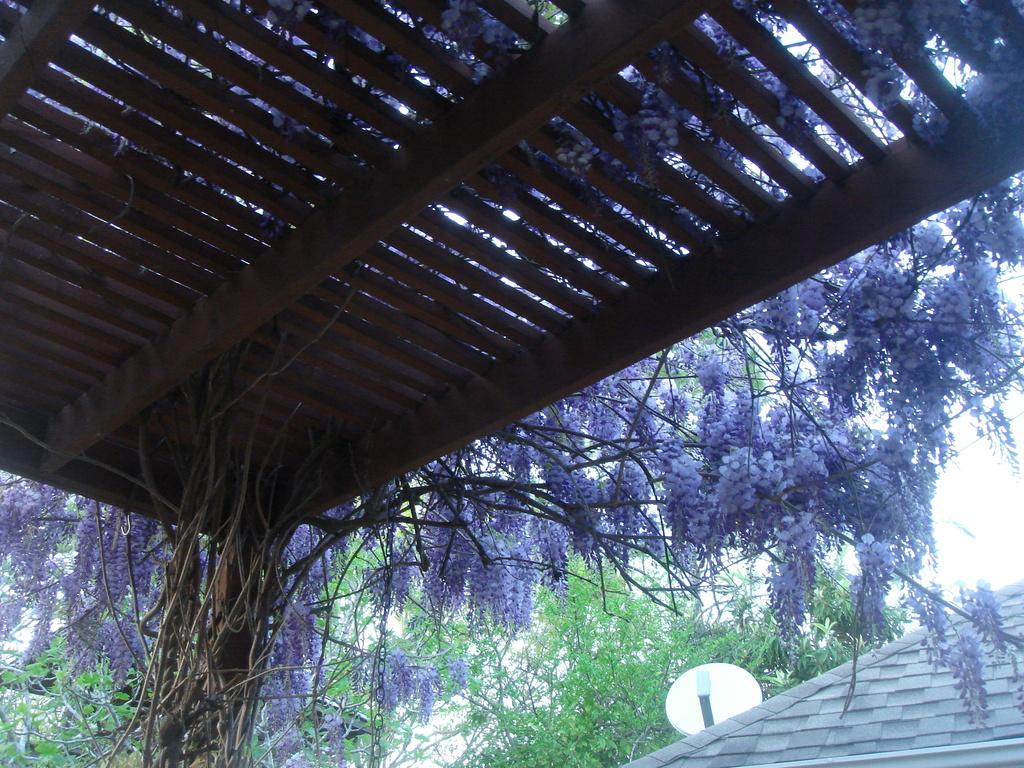What type of structure is in the image? There is a wooden shed in the image. What natural elements can be seen in the image? Trees and plants are visible in the image. What part of a house can be seen in the image? A house roof is visible in the image. What is placed on the house roof? There is a dish on the house roof. What type of fuel is being stored in the wooden shed in the image? There is no indication of any fuel being stored in the wooden shed in the image. Who might be sitting on the throne in the image? There is no throne present in the image. 